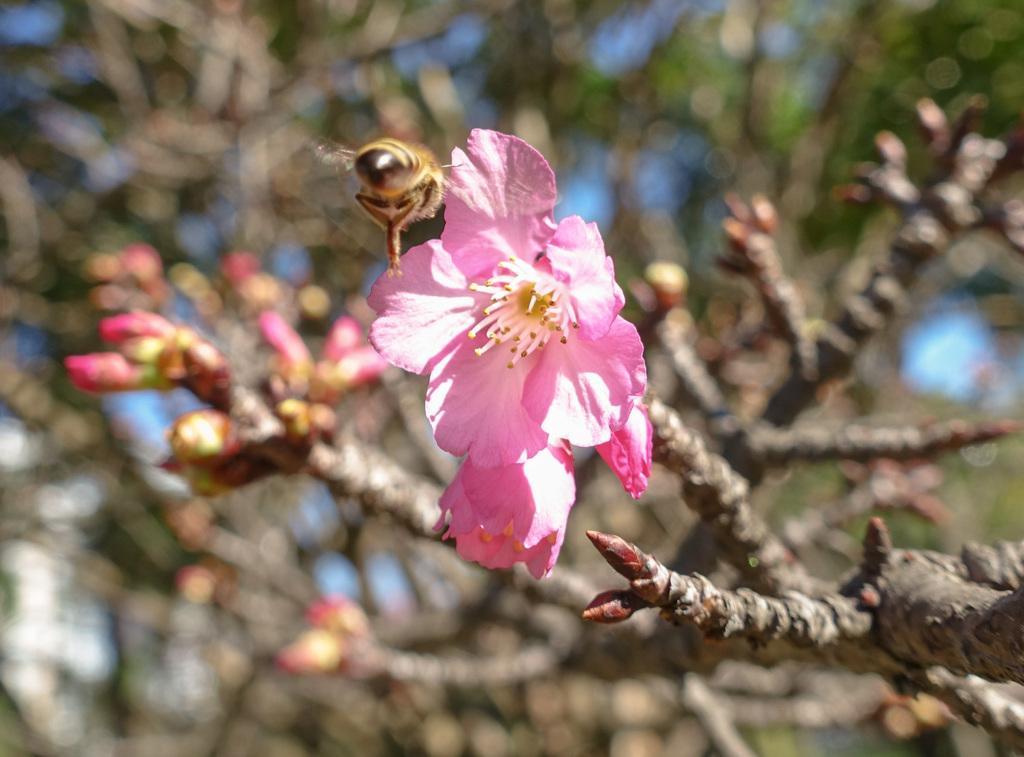How would you summarize this image in a sentence or two? In this image I can see a flower which is pink in color to the tree and an insect which is brown, yellow and black in color. I can see the blurry background in which I can see few flowers to the tree and the sky. 